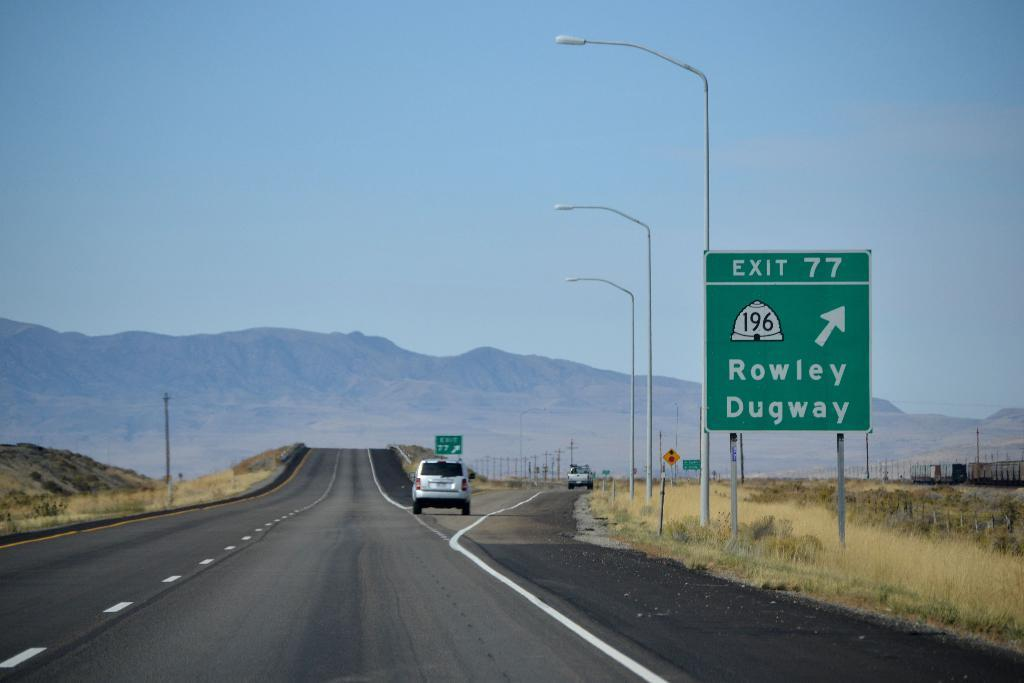<image>
Summarize the visual content of the image. A green road sign that says Rowley and Dugway to the right. 